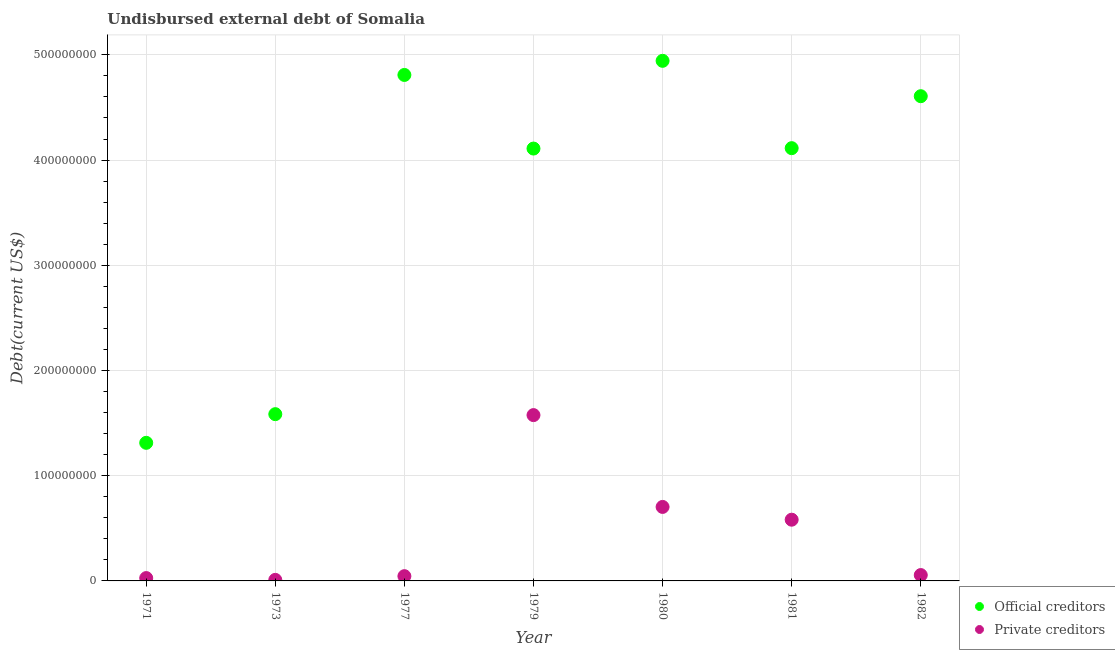How many different coloured dotlines are there?
Provide a succinct answer. 2. Is the number of dotlines equal to the number of legend labels?
Keep it short and to the point. Yes. What is the undisbursed external debt of private creditors in 1977?
Offer a very short reply. 4.53e+06. Across all years, what is the maximum undisbursed external debt of official creditors?
Keep it short and to the point. 4.94e+08. Across all years, what is the minimum undisbursed external debt of private creditors?
Your answer should be compact. 1.00e+06. In which year was the undisbursed external debt of official creditors maximum?
Your response must be concise. 1980. In which year was the undisbursed external debt of private creditors minimum?
Your answer should be very brief. 1973. What is the total undisbursed external debt of official creditors in the graph?
Give a very brief answer. 2.55e+09. What is the difference between the undisbursed external debt of official creditors in 1971 and that in 1980?
Ensure brevity in your answer.  -3.63e+08. What is the difference between the undisbursed external debt of official creditors in 1982 and the undisbursed external debt of private creditors in 1979?
Offer a terse response. 3.03e+08. What is the average undisbursed external debt of official creditors per year?
Your answer should be compact. 3.64e+08. In the year 1979, what is the difference between the undisbursed external debt of official creditors and undisbursed external debt of private creditors?
Provide a succinct answer. 2.53e+08. What is the ratio of the undisbursed external debt of private creditors in 1981 to that in 1982?
Give a very brief answer. 10.45. Is the undisbursed external debt of private creditors in 1973 less than that in 1980?
Give a very brief answer. Yes. Is the difference between the undisbursed external debt of official creditors in 1980 and 1981 greater than the difference between the undisbursed external debt of private creditors in 1980 and 1981?
Your answer should be very brief. Yes. What is the difference between the highest and the second highest undisbursed external debt of private creditors?
Your response must be concise. 8.73e+07. What is the difference between the highest and the lowest undisbursed external debt of official creditors?
Offer a very short reply. 3.63e+08. In how many years, is the undisbursed external debt of official creditors greater than the average undisbursed external debt of official creditors taken over all years?
Offer a very short reply. 5. Does the undisbursed external debt of private creditors monotonically increase over the years?
Offer a terse response. No. How many years are there in the graph?
Your answer should be very brief. 7. Does the graph contain grids?
Your answer should be very brief. Yes. Where does the legend appear in the graph?
Provide a succinct answer. Bottom right. What is the title of the graph?
Provide a succinct answer. Undisbursed external debt of Somalia. Does "current US$" appear as one of the legend labels in the graph?
Offer a terse response. No. What is the label or title of the X-axis?
Ensure brevity in your answer.  Year. What is the label or title of the Y-axis?
Keep it short and to the point. Debt(current US$). What is the Debt(current US$) in Official creditors in 1971?
Your response must be concise. 1.31e+08. What is the Debt(current US$) of Private creditors in 1971?
Ensure brevity in your answer.  2.71e+06. What is the Debt(current US$) in Official creditors in 1973?
Provide a succinct answer. 1.58e+08. What is the Debt(current US$) in Official creditors in 1977?
Offer a terse response. 4.81e+08. What is the Debt(current US$) in Private creditors in 1977?
Provide a succinct answer. 4.53e+06. What is the Debt(current US$) of Official creditors in 1979?
Give a very brief answer. 4.11e+08. What is the Debt(current US$) of Private creditors in 1979?
Provide a short and direct response. 1.58e+08. What is the Debt(current US$) in Official creditors in 1980?
Keep it short and to the point. 4.94e+08. What is the Debt(current US$) in Private creditors in 1980?
Your response must be concise. 7.03e+07. What is the Debt(current US$) in Official creditors in 1981?
Provide a succinct answer. 4.11e+08. What is the Debt(current US$) in Private creditors in 1981?
Ensure brevity in your answer.  5.82e+07. What is the Debt(current US$) in Official creditors in 1982?
Provide a succinct answer. 4.61e+08. What is the Debt(current US$) in Private creditors in 1982?
Provide a succinct answer. 5.57e+06. Across all years, what is the maximum Debt(current US$) in Official creditors?
Your response must be concise. 4.94e+08. Across all years, what is the maximum Debt(current US$) in Private creditors?
Your response must be concise. 1.58e+08. Across all years, what is the minimum Debt(current US$) of Official creditors?
Keep it short and to the point. 1.31e+08. Across all years, what is the minimum Debt(current US$) of Private creditors?
Make the answer very short. 1.00e+06. What is the total Debt(current US$) in Official creditors in the graph?
Your answer should be very brief. 2.55e+09. What is the total Debt(current US$) of Private creditors in the graph?
Offer a terse response. 3.00e+08. What is the difference between the Debt(current US$) in Official creditors in 1971 and that in 1973?
Offer a very short reply. -2.72e+07. What is the difference between the Debt(current US$) in Private creditors in 1971 and that in 1973?
Provide a succinct answer. 1.71e+06. What is the difference between the Debt(current US$) in Official creditors in 1971 and that in 1977?
Offer a terse response. -3.50e+08. What is the difference between the Debt(current US$) in Private creditors in 1971 and that in 1977?
Offer a very short reply. -1.82e+06. What is the difference between the Debt(current US$) of Official creditors in 1971 and that in 1979?
Your response must be concise. -2.80e+08. What is the difference between the Debt(current US$) in Private creditors in 1971 and that in 1979?
Your response must be concise. -1.55e+08. What is the difference between the Debt(current US$) of Official creditors in 1971 and that in 1980?
Keep it short and to the point. -3.63e+08. What is the difference between the Debt(current US$) of Private creditors in 1971 and that in 1980?
Your answer should be compact. -6.76e+07. What is the difference between the Debt(current US$) in Official creditors in 1971 and that in 1981?
Make the answer very short. -2.80e+08. What is the difference between the Debt(current US$) in Private creditors in 1971 and that in 1981?
Offer a terse response. -5.55e+07. What is the difference between the Debt(current US$) of Official creditors in 1971 and that in 1982?
Your answer should be very brief. -3.29e+08. What is the difference between the Debt(current US$) of Private creditors in 1971 and that in 1982?
Keep it short and to the point. -2.86e+06. What is the difference between the Debt(current US$) of Official creditors in 1973 and that in 1977?
Your answer should be compact. -3.22e+08. What is the difference between the Debt(current US$) of Private creditors in 1973 and that in 1977?
Your answer should be very brief. -3.53e+06. What is the difference between the Debt(current US$) in Official creditors in 1973 and that in 1979?
Keep it short and to the point. -2.52e+08. What is the difference between the Debt(current US$) in Private creditors in 1973 and that in 1979?
Your answer should be very brief. -1.57e+08. What is the difference between the Debt(current US$) in Official creditors in 1973 and that in 1980?
Provide a succinct answer. -3.36e+08. What is the difference between the Debt(current US$) in Private creditors in 1973 and that in 1980?
Your answer should be very brief. -6.93e+07. What is the difference between the Debt(current US$) of Official creditors in 1973 and that in 1981?
Give a very brief answer. -2.53e+08. What is the difference between the Debt(current US$) of Private creditors in 1973 and that in 1981?
Ensure brevity in your answer.  -5.72e+07. What is the difference between the Debt(current US$) in Official creditors in 1973 and that in 1982?
Provide a succinct answer. -3.02e+08. What is the difference between the Debt(current US$) in Private creditors in 1973 and that in 1982?
Your answer should be very brief. -4.57e+06. What is the difference between the Debt(current US$) in Official creditors in 1977 and that in 1979?
Offer a very short reply. 7.00e+07. What is the difference between the Debt(current US$) of Private creditors in 1977 and that in 1979?
Provide a succinct answer. -1.53e+08. What is the difference between the Debt(current US$) of Official creditors in 1977 and that in 1980?
Provide a succinct answer. -1.34e+07. What is the difference between the Debt(current US$) of Private creditors in 1977 and that in 1980?
Provide a short and direct response. -6.58e+07. What is the difference between the Debt(current US$) in Official creditors in 1977 and that in 1981?
Provide a short and direct response. 6.96e+07. What is the difference between the Debt(current US$) in Private creditors in 1977 and that in 1981?
Ensure brevity in your answer.  -5.37e+07. What is the difference between the Debt(current US$) in Official creditors in 1977 and that in 1982?
Your response must be concise. 2.02e+07. What is the difference between the Debt(current US$) in Private creditors in 1977 and that in 1982?
Provide a short and direct response. -1.04e+06. What is the difference between the Debt(current US$) of Official creditors in 1979 and that in 1980?
Give a very brief answer. -8.34e+07. What is the difference between the Debt(current US$) in Private creditors in 1979 and that in 1980?
Provide a short and direct response. 8.73e+07. What is the difference between the Debt(current US$) in Official creditors in 1979 and that in 1981?
Your response must be concise. -3.84e+05. What is the difference between the Debt(current US$) in Private creditors in 1979 and that in 1981?
Offer a terse response. 9.94e+07. What is the difference between the Debt(current US$) of Official creditors in 1979 and that in 1982?
Offer a very short reply. -4.98e+07. What is the difference between the Debt(current US$) of Private creditors in 1979 and that in 1982?
Offer a very short reply. 1.52e+08. What is the difference between the Debt(current US$) of Official creditors in 1980 and that in 1981?
Your answer should be very brief. 8.30e+07. What is the difference between the Debt(current US$) of Private creditors in 1980 and that in 1981?
Ensure brevity in your answer.  1.21e+07. What is the difference between the Debt(current US$) of Official creditors in 1980 and that in 1982?
Keep it short and to the point. 3.36e+07. What is the difference between the Debt(current US$) in Private creditors in 1980 and that in 1982?
Keep it short and to the point. 6.48e+07. What is the difference between the Debt(current US$) of Official creditors in 1981 and that in 1982?
Offer a terse response. -4.94e+07. What is the difference between the Debt(current US$) of Private creditors in 1981 and that in 1982?
Ensure brevity in your answer.  5.26e+07. What is the difference between the Debt(current US$) in Official creditors in 1971 and the Debt(current US$) in Private creditors in 1973?
Your answer should be very brief. 1.30e+08. What is the difference between the Debt(current US$) in Official creditors in 1971 and the Debt(current US$) in Private creditors in 1977?
Your answer should be compact. 1.27e+08. What is the difference between the Debt(current US$) of Official creditors in 1971 and the Debt(current US$) of Private creditors in 1979?
Keep it short and to the point. -2.63e+07. What is the difference between the Debt(current US$) in Official creditors in 1971 and the Debt(current US$) in Private creditors in 1980?
Keep it short and to the point. 6.09e+07. What is the difference between the Debt(current US$) in Official creditors in 1971 and the Debt(current US$) in Private creditors in 1981?
Your response must be concise. 7.31e+07. What is the difference between the Debt(current US$) of Official creditors in 1971 and the Debt(current US$) of Private creditors in 1982?
Keep it short and to the point. 1.26e+08. What is the difference between the Debt(current US$) of Official creditors in 1973 and the Debt(current US$) of Private creditors in 1977?
Provide a succinct answer. 1.54e+08. What is the difference between the Debt(current US$) of Official creditors in 1973 and the Debt(current US$) of Private creditors in 1979?
Your answer should be compact. 8.96e+05. What is the difference between the Debt(current US$) in Official creditors in 1973 and the Debt(current US$) in Private creditors in 1980?
Offer a terse response. 8.82e+07. What is the difference between the Debt(current US$) of Official creditors in 1973 and the Debt(current US$) of Private creditors in 1981?
Offer a very short reply. 1.00e+08. What is the difference between the Debt(current US$) of Official creditors in 1973 and the Debt(current US$) of Private creditors in 1982?
Your response must be concise. 1.53e+08. What is the difference between the Debt(current US$) in Official creditors in 1977 and the Debt(current US$) in Private creditors in 1979?
Your answer should be compact. 3.23e+08. What is the difference between the Debt(current US$) of Official creditors in 1977 and the Debt(current US$) of Private creditors in 1980?
Offer a terse response. 4.11e+08. What is the difference between the Debt(current US$) in Official creditors in 1977 and the Debt(current US$) in Private creditors in 1981?
Your response must be concise. 4.23e+08. What is the difference between the Debt(current US$) in Official creditors in 1977 and the Debt(current US$) in Private creditors in 1982?
Provide a short and direct response. 4.75e+08. What is the difference between the Debt(current US$) of Official creditors in 1979 and the Debt(current US$) of Private creditors in 1980?
Make the answer very short. 3.41e+08. What is the difference between the Debt(current US$) in Official creditors in 1979 and the Debt(current US$) in Private creditors in 1981?
Offer a very short reply. 3.53e+08. What is the difference between the Debt(current US$) in Official creditors in 1979 and the Debt(current US$) in Private creditors in 1982?
Your answer should be very brief. 4.05e+08. What is the difference between the Debt(current US$) of Official creditors in 1980 and the Debt(current US$) of Private creditors in 1981?
Your answer should be very brief. 4.36e+08. What is the difference between the Debt(current US$) in Official creditors in 1980 and the Debt(current US$) in Private creditors in 1982?
Your answer should be very brief. 4.89e+08. What is the difference between the Debt(current US$) in Official creditors in 1981 and the Debt(current US$) in Private creditors in 1982?
Your answer should be very brief. 4.06e+08. What is the average Debt(current US$) in Official creditors per year?
Make the answer very short. 3.64e+08. What is the average Debt(current US$) in Private creditors per year?
Your response must be concise. 4.28e+07. In the year 1971, what is the difference between the Debt(current US$) of Official creditors and Debt(current US$) of Private creditors?
Ensure brevity in your answer.  1.29e+08. In the year 1973, what is the difference between the Debt(current US$) of Official creditors and Debt(current US$) of Private creditors?
Ensure brevity in your answer.  1.57e+08. In the year 1977, what is the difference between the Debt(current US$) in Official creditors and Debt(current US$) in Private creditors?
Make the answer very short. 4.76e+08. In the year 1979, what is the difference between the Debt(current US$) of Official creditors and Debt(current US$) of Private creditors?
Offer a very short reply. 2.53e+08. In the year 1980, what is the difference between the Debt(current US$) in Official creditors and Debt(current US$) in Private creditors?
Keep it short and to the point. 4.24e+08. In the year 1981, what is the difference between the Debt(current US$) in Official creditors and Debt(current US$) in Private creditors?
Ensure brevity in your answer.  3.53e+08. In the year 1982, what is the difference between the Debt(current US$) in Official creditors and Debt(current US$) in Private creditors?
Keep it short and to the point. 4.55e+08. What is the ratio of the Debt(current US$) in Official creditors in 1971 to that in 1973?
Your response must be concise. 0.83. What is the ratio of the Debt(current US$) of Private creditors in 1971 to that in 1973?
Provide a short and direct response. 2.71. What is the ratio of the Debt(current US$) in Official creditors in 1971 to that in 1977?
Offer a very short reply. 0.27. What is the ratio of the Debt(current US$) in Private creditors in 1971 to that in 1977?
Ensure brevity in your answer.  0.6. What is the ratio of the Debt(current US$) of Official creditors in 1971 to that in 1979?
Your answer should be compact. 0.32. What is the ratio of the Debt(current US$) of Private creditors in 1971 to that in 1979?
Provide a succinct answer. 0.02. What is the ratio of the Debt(current US$) in Official creditors in 1971 to that in 1980?
Give a very brief answer. 0.27. What is the ratio of the Debt(current US$) of Private creditors in 1971 to that in 1980?
Provide a short and direct response. 0.04. What is the ratio of the Debt(current US$) of Official creditors in 1971 to that in 1981?
Provide a succinct answer. 0.32. What is the ratio of the Debt(current US$) in Private creditors in 1971 to that in 1981?
Keep it short and to the point. 0.05. What is the ratio of the Debt(current US$) of Official creditors in 1971 to that in 1982?
Your response must be concise. 0.28. What is the ratio of the Debt(current US$) in Private creditors in 1971 to that in 1982?
Provide a short and direct response. 0.49. What is the ratio of the Debt(current US$) of Official creditors in 1973 to that in 1977?
Your response must be concise. 0.33. What is the ratio of the Debt(current US$) in Private creditors in 1973 to that in 1977?
Make the answer very short. 0.22. What is the ratio of the Debt(current US$) of Official creditors in 1973 to that in 1979?
Keep it short and to the point. 0.39. What is the ratio of the Debt(current US$) of Private creditors in 1973 to that in 1979?
Give a very brief answer. 0.01. What is the ratio of the Debt(current US$) of Official creditors in 1973 to that in 1980?
Ensure brevity in your answer.  0.32. What is the ratio of the Debt(current US$) of Private creditors in 1973 to that in 1980?
Offer a very short reply. 0.01. What is the ratio of the Debt(current US$) in Official creditors in 1973 to that in 1981?
Your answer should be very brief. 0.39. What is the ratio of the Debt(current US$) of Private creditors in 1973 to that in 1981?
Provide a succinct answer. 0.02. What is the ratio of the Debt(current US$) in Official creditors in 1973 to that in 1982?
Your answer should be very brief. 0.34. What is the ratio of the Debt(current US$) of Private creditors in 1973 to that in 1982?
Give a very brief answer. 0.18. What is the ratio of the Debt(current US$) of Official creditors in 1977 to that in 1979?
Your answer should be compact. 1.17. What is the ratio of the Debt(current US$) in Private creditors in 1977 to that in 1979?
Your answer should be compact. 0.03. What is the ratio of the Debt(current US$) of Official creditors in 1977 to that in 1980?
Offer a terse response. 0.97. What is the ratio of the Debt(current US$) in Private creditors in 1977 to that in 1980?
Offer a very short reply. 0.06. What is the ratio of the Debt(current US$) in Official creditors in 1977 to that in 1981?
Keep it short and to the point. 1.17. What is the ratio of the Debt(current US$) in Private creditors in 1977 to that in 1981?
Ensure brevity in your answer.  0.08. What is the ratio of the Debt(current US$) in Official creditors in 1977 to that in 1982?
Make the answer very short. 1.04. What is the ratio of the Debt(current US$) in Private creditors in 1977 to that in 1982?
Offer a terse response. 0.81. What is the ratio of the Debt(current US$) of Official creditors in 1979 to that in 1980?
Your response must be concise. 0.83. What is the ratio of the Debt(current US$) in Private creditors in 1979 to that in 1980?
Your answer should be very brief. 2.24. What is the ratio of the Debt(current US$) of Official creditors in 1979 to that in 1981?
Offer a terse response. 1. What is the ratio of the Debt(current US$) in Private creditors in 1979 to that in 1981?
Provide a short and direct response. 2.71. What is the ratio of the Debt(current US$) in Official creditors in 1979 to that in 1982?
Offer a very short reply. 0.89. What is the ratio of the Debt(current US$) in Private creditors in 1979 to that in 1982?
Your answer should be very brief. 28.31. What is the ratio of the Debt(current US$) of Official creditors in 1980 to that in 1981?
Provide a succinct answer. 1.2. What is the ratio of the Debt(current US$) of Private creditors in 1980 to that in 1981?
Give a very brief answer. 1.21. What is the ratio of the Debt(current US$) of Official creditors in 1980 to that in 1982?
Provide a short and direct response. 1.07. What is the ratio of the Debt(current US$) of Private creditors in 1980 to that in 1982?
Offer a very short reply. 12.63. What is the ratio of the Debt(current US$) of Official creditors in 1981 to that in 1982?
Your answer should be compact. 0.89. What is the ratio of the Debt(current US$) of Private creditors in 1981 to that in 1982?
Your answer should be very brief. 10.45. What is the difference between the highest and the second highest Debt(current US$) in Official creditors?
Ensure brevity in your answer.  1.34e+07. What is the difference between the highest and the second highest Debt(current US$) of Private creditors?
Make the answer very short. 8.73e+07. What is the difference between the highest and the lowest Debt(current US$) in Official creditors?
Offer a terse response. 3.63e+08. What is the difference between the highest and the lowest Debt(current US$) of Private creditors?
Keep it short and to the point. 1.57e+08. 